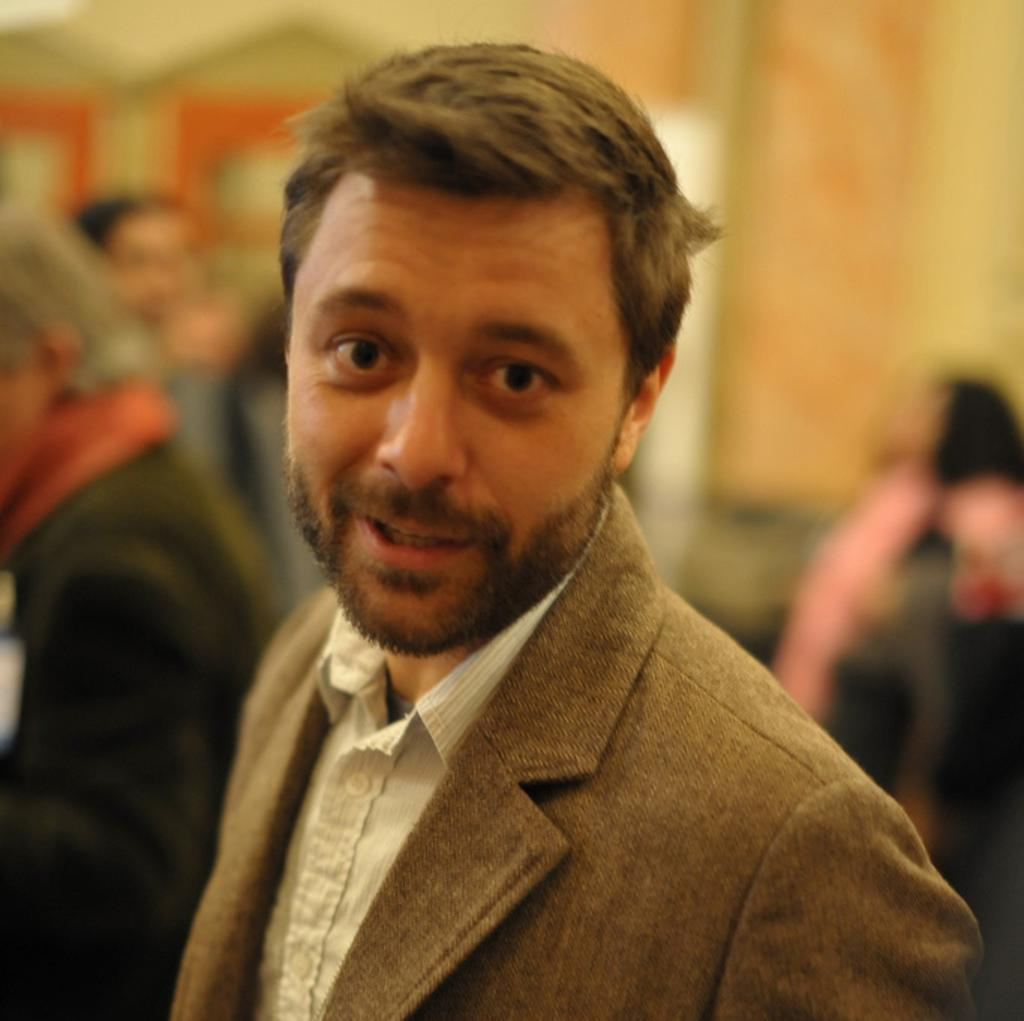Who is the main subject in the image? There is a man in the center of the image. What is the man doing in the image? The man is standing and smiling. Can you describe the background of the image? The background of the image is blurry. How many trees can be seen in the image? There are no trees visible in the image; it features a man standing in the center with a blurry background. 